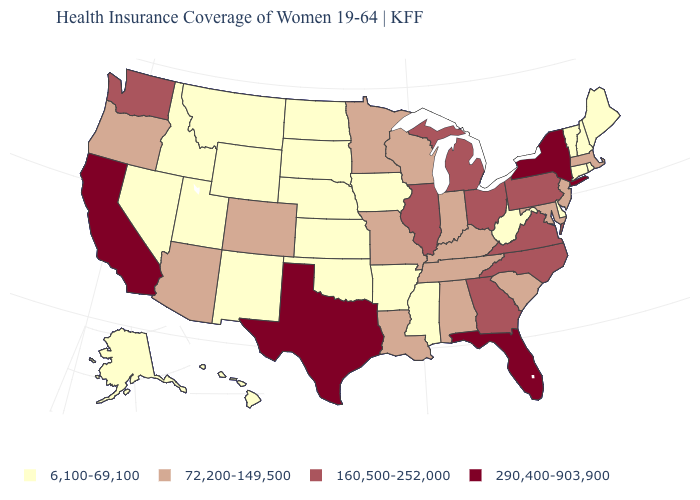Does Virginia have a higher value than Hawaii?
Answer briefly. Yes. Among the states that border Connecticut , does Rhode Island have the lowest value?
Give a very brief answer. Yes. Among the states that border Georgia , which have the highest value?
Concise answer only. Florida. Name the states that have a value in the range 290,400-903,900?
Answer briefly. California, Florida, New York, Texas. What is the highest value in the USA?
Quick response, please. 290,400-903,900. Does Minnesota have a lower value than Iowa?
Concise answer only. No. What is the highest value in states that border Arizona?
Answer briefly. 290,400-903,900. Does South Carolina have the same value as Maryland?
Be succinct. Yes. Does Arkansas have the lowest value in the USA?
Write a very short answer. Yes. Does Mississippi have the highest value in the USA?
Give a very brief answer. No. Name the states that have a value in the range 6,100-69,100?
Be succinct. Alaska, Arkansas, Connecticut, Delaware, Hawaii, Idaho, Iowa, Kansas, Maine, Mississippi, Montana, Nebraska, Nevada, New Hampshire, New Mexico, North Dakota, Oklahoma, Rhode Island, South Dakota, Utah, Vermont, West Virginia, Wyoming. What is the value of Vermont?
Be succinct. 6,100-69,100. Among the states that border Wyoming , which have the lowest value?
Keep it brief. Idaho, Montana, Nebraska, South Dakota, Utah. What is the highest value in the South ?
Keep it brief. 290,400-903,900. How many symbols are there in the legend?
Answer briefly. 4. 